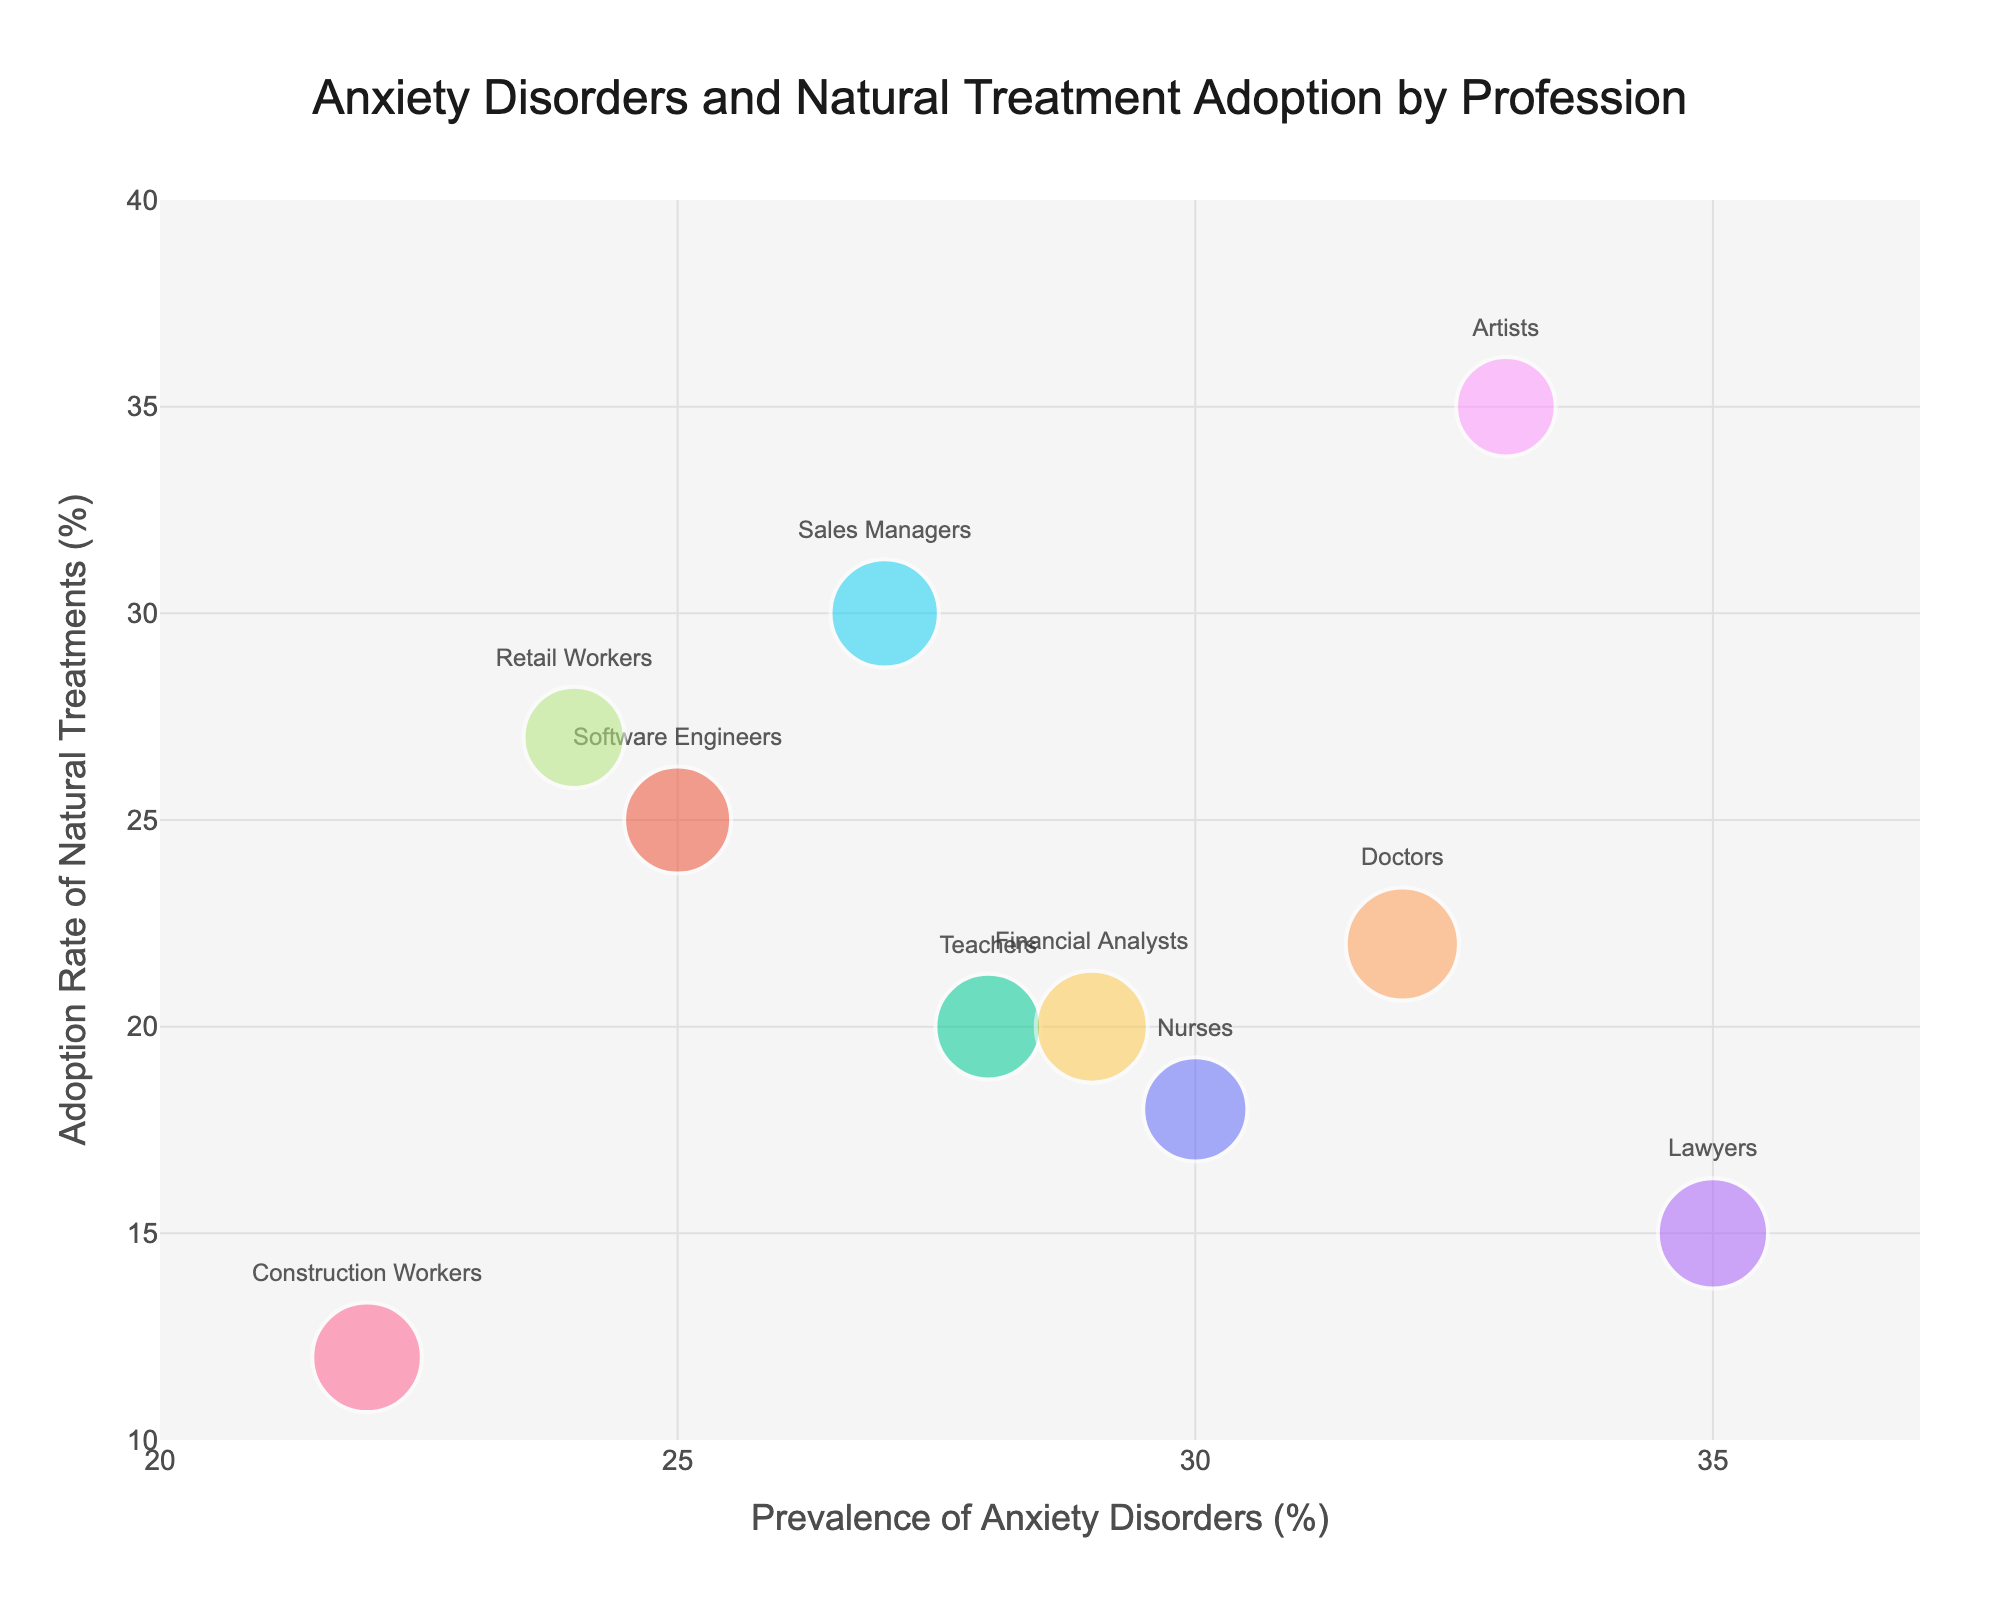What is the title of the bubble chart? The title of the bubble chart is located at the top and center of the chart. It reads "Anxiety Disorders and Natural Treatment Adoption by Profession".
Answer: Anxiety Disorders and Natural Treatment Adoption by Profession Which profession has the highest prevalence of anxiety disorders? To determine the profession with the highest prevalence, look for the data point with the highest x-axis value. Lawyers have the highest prevalence at 35%.
Answer: Lawyers Which profession has the highest adoption rate of natural treatments? Look at the y-axis to find the profession with the highest value. Artists have the highest adoption rate at 35%.
Answer: Artists What is the range of the x-axis values? The x-axis is marked with tick marks and numbers. The range starts at 20% and goes up to 37%.
Answer: 20% to 37% How many professions have a prevalence of anxiety disorders greater than or equal to 30%? Count the data points where the x-axis value is 30% or higher. There are four professions: Nurses (30%), Lawyers (35%), Doctors (32%), and Artists (33%).
Answer: Four Which profession has the largest bubble size, and what might that indicate? Bubble size represents the average work hours per week. Larger bubble size indicates more work hours. Doctors have the largest bubble, indicating they work around 50 hours per week.
Answer: Doctors Compare Nurses and Teachers in terms of prevalence of anxiety disorders and adoption rate of natural treatments. Check the respective x and y values for Nurses and Teachers. Nurses (30%, 18%) and Teachers (28%, 20%). Nurses have a slightly higher prevalence of anxiety disorders, but Teachers have a slightly higher adoption rate of natural treatments.
Answer: Nurses have higher prevalence, Teachers have higher adoption rate Which profession works more hours on average, Sales Managers or Construction Workers? Compare the bubble sizes to see which is larger. Sales Managers have larger bubbles, indicating they work around 42 hours per week, while Construction Workers work around 44 hours per week. This indicates Construction Workers work more weekly hours.
Answer: Construction Workers What is the adoption rate of natural treatments for Financial Analysts? Find the y-axis value corresponding to Financial Analysts. It is 20%.
Answer: 20% Calculate the average adoption rate of natural treatments for professions with more than 30% prevalence of anxiety disorders. Identify the professions: Lawyers (15%), Doctors (22%), Artists (35%). Add the y-values and divide by the number of professions: (15% + 22% + 35%) / 3 = 24%.
Answer: 24% 